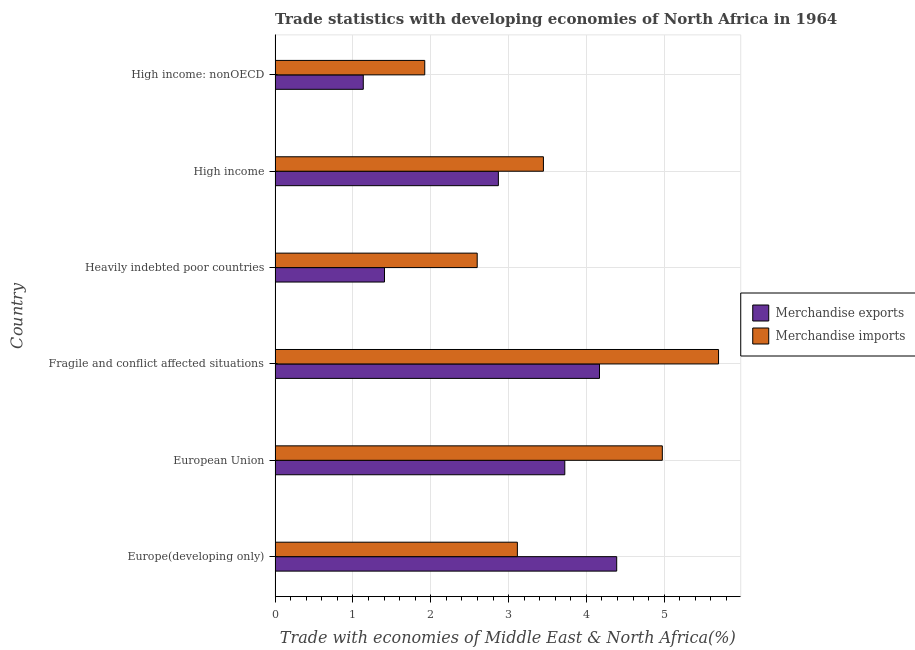How many different coloured bars are there?
Keep it short and to the point. 2. Are the number of bars on each tick of the Y-axis equal?
Provide a succinct answer. Yes. How many bars are there on the 1st tick from the bottom?
Ensure brevity in your answer.  2. What is the label of the 6th group of bars from the top?
Your response must be concise. Europe(developing only). What is the merchandise exports in Europe(developing only)?
Offer a very short reply. 4.39. Across all countries, what is the maximum merchandise exports?
Give a very brief answer. 4.39. Across all countries, what is the minimum merchandise exports?
Your answer should be very brief. 1.13. In which country was the merchandise exports maximum?
Give a very brief answer. Europe(developing only). In which country was the merchandise exports minimum?
Offer a terse response. High income: nonOECD. What is the total merchandise imports in the graph?
Your answer should be compact. 21.76. What is the difference between the merchandise imports in European Union and that in High income?
Provide a short and direct response. 1.53. What is the difference between the merchandise imports in High income and the merchandise exports in High income: nonOECD?
Offer a very short reply. 2.31. What is the average merchandise exports per country?
Ensure brevity in your answer.  2.95. What is the difference between the merchandise imports and merchandise exports in Fragile and conflict affected situations?
Offer a terse response. 1.53. In how many countries, is the merchandise imports greater than 0.2 %?
Ensure brevity in your answer.  6. What is the ratio of the merchandise imports in Fragile and conflict affected situations to that in High income?
Ensure brevity in your answer.  1.65. Is the merchandise exports in Fragile and conflict affected situations less than that in High income: nonOECD?
Offer a very short reply. No. What is the difference between the highest and the second highest merchandise imports?
Make the answer very short. 0.72. What is the difference between the highest and the lowest merchandise exports?
Your answer should be very brief. 3.26. What does the 2nd bar from the top in High income represents?
Offer a very short reply. Merchandise exports. What does the 1st bar from the bottom in Fragile and conflict affected situations represents?
Your answer should be compact. Merchandise exports. Are all the bars in the graph horizontal?
Provide a succinct answer. Yes. Are the values on the major ticks of X-axis written in scientific E-notation?
Give a very brief answer. No. Where does the legend appear in the graph?
Make the answer very short. Center right. How are the legend labels stacked?
Keep it short and to the point. Vertical. What is the title of the graph?
Keep it short and to the point. Trade statistics with developing economies of North Africa in 1964. What is the label or title of the X-axis?
Offer a very short reply. Trade with economies of Middle East & North Africa(%). What is the label or title of the Y-axis?
Your response must be concise. Country. What is the Trade with economies of Middle East & North Africa(%) of Merchandise exports in Europe(developing only)?
Provide a succinct answer. 4.39. What is the Trade with economies of Middle East & North Africa(%) in Merchandise imports in Europe(developing only)?
Offer a very short reply. 3.11. What is the Trade with economies of Middle East & North Africa(%) of Merchandise exports in European Union?
Offer a terse response. 3.72. What is the Trade with economies of Middle East & North Africa(%) in Merchandise imports in European Union?
Offer a terse response. 4.98. What is the Trade with economies of Middle East & North Africa(%) of Merchandise exports in Fragile and conflict affected situations?
Keep it short and to the point. 4.17. What is the Trade with economies of Middle East & North Africa(%) of Merchandise imports in Fragile and conflict affected situations?
Offer a terse response. 5.7. What is the Trade with economies of Middle East & North Africa(%) in Merchandise exports in Heavily indebted poor countries?
Offer a terse response. 1.41. What is the Trade with economies of Middle East & North Africa(%) in Merchandise imports in Heavily indebted poor countries?
Provide a short and direct response. 2.6. What is the Trade with economies of Middle East & North Africa(%) of Merchandise exports in High income?
Offer a terse response. 2.87. What is the Trade with economies of Middle East & North Africa(%) of Merchandise imports in High income?
Provide a succinct answer. 3.45. What is the Trade with economies of Middle East & North Africa(%) in Merchandise exports in High income: nonOECD?
Offer a terse response. 1.13. What is the Trade with economies of Middle East & North Africa(%) in Merchandise imports in High income: nonOECD?
Offer a terse response. 1.92. Across all countries, what is the maximum Trade with economies of Middle East & North Africa(%) in Merchandise exports?
Provide a succinct answer. 4.39. Across all countries, what is the maximum Trade with economies of Middle East & North Africa(%) in Merchandise imports?
Offer a terse response. 5.7. Across all countries, what is the minimum Trade with economies of Middle East & North Africa(%) in Merchandise exports?
Your response must be concise. 1.13. Across all countries, what is the minimum Trade with economies of Middle East & North Africa(%) of Merchandise imports?
Offer a terse response. 1.92. What is the total Trade with economies of Middle East & North Africa(%) of Merchandise exports in the graph?
Provide a short and direct response. 17.69. What is the total Trade with economies of Middle East & North Africa(%) in Merchandise imports in the graph?
Make the answer very short. 21.75. What is the difference between the Trade with economies of Middle East & North Africa(%) of Merchandise exports in Europe(developing only) and that in European Union?
Make the answer very short. 0.67. What is the difference between the Trade with economies of Middle East & North Africa(%) of Merchandise imports in Europe(developing only) and that in European Union?
Your answer should be very brief. -1.86. What is the difference between the Trade with economies of Middle East & North Africa(%) of Merchandise exports in Europe(developing only) and that in Fragile and conflict affected situations?
Provide a succinct answer. 0.22. What is the difference between the Trade with economies of Middle East & North Africa(%) of Merchandise imports in Europe(developing only) and that in Fragile and conflict affected situations?
Your answer should be compact. -2.58. What is the difference between the Trade with economies of Middle East & North Africa(%) of Merchandise exports in Europe(developing only) and that in Heavily indebted poor countries?
Your answer should be compact. 2.98. What is the difference between the Trade with economies of Middle East & North Africa(%) in Merchandise imports in Europe(developing only) and that in Heavily indebted poor countries?
Provide a succinct answer. 0.52. What is the difference between the Trade with economies of Middle East & North Africa(%) in Merchandise exports in Europe(developing only) and that in High income?
Provide a succinct answer. 1.52. What is the difference between the Trade with economies of Middle East & North Africa(%) of Merchandise imports in Europe(developing only) and that in High income?
Offer a very short reply. -0.33. What is the difference between the Trade with economies of Middle East & North Africa(%) of Merchandise exports in Europe(developing only) and that in High income: nonOECD?
Your answer should be compact. 3.26. What is the difference between the Trade with economies of Middle East & North Africa(%) in Merchandise imports in Europe(developing only) and that in High income: nonOECD?
Give a very brief answer. 1.19. What is the difference between the Trade with economies of Middle East & North Africa(%) in Merchandise exports in European Union and that in Fragile and conflict affected situations?
Your response must be concise. -0.45. What is the difference between the Trade with economies of Middle East & North Africa(%) in Merchandise imports in European Union and that in Fragile and conflict affected situations?
Provide a short and direct response. -0.72. What is the difference between the Trade with economies of Middle East & North Africa(%) in Merchandise exports in European Union and that in Heavily indebted poor countries?
Keep it short and to the point. 2.32. What is the difference between the Trade with economies of Middle East & North Africa(%) in Merchandise imports in European Union and that in Heavily indebted poor countries?
Provide a short and direct response. 2.38. What is the difference between the Trade with economies of Middle East & North Africa(%) in Merchandise exports in European Union and that in High income?
Provide a succinct answer. 0.85. What is the difference between the Trade with economies of Middle East & North Africa(%) in Merchandise imports in European Union and that in High income?
Offer a very short reply. 1.53. What is the difference between the Trade with economies of Middle East & North Africa(%) of Merchandise exports in European Union and that in High income: nonOECD?
Ensure brevity in your answer.  2.59. What is the difference between the Trade with economies of Middle East & North Africa(%) of Merchandise imports in European Union and that in High income: nonOECD?
Give a very brief answer. 3.05. What is the difference between the Trade with economies of Middle East & North Africa(%) in Merchandise exports in Fragile and conflict affected situations and that in Heavily indebted poor countries?
Make the answer very short. 2.76. What is the difference between the Trade with economies of Middle East & North Africa(%) in Merchandise imports in Fragile and conflict affected situations and that in Heavily indebted poor countries?
Offer a very short reply. 3.1. What is the difference between the Trade with economies of Middle East & North Africa(%) of Merchandise exports in Fragile and conflict affected situations and that in High income?
Keep it short and to the point. 1.3. What is the difference between the Trade with economies of Middle East & North Africa(%) of Merchandise imports in Fragile and conflict affected situations and that in High income?
Your answer should be very brief. 2.25. What is the difference between the Trade with economies of Middle East & North Africa(%) of Merchandise exports in Fragile and conflict affected situations and that in High income: nonOECD?
Your answer should be very brief. 3.04. What is the difference between the Trade with economies of Middle East & North Africa(%) in Merchandise imports in Fragile and conflict affected situations and that in High income: nonOECD?
Offer a terse response. 3.77. What is the difference between the Trade with economies of Middle East & North Africa(%) in Merchandise exports in Heavily indebted poor countries and that in High income?
Your answer should be very brief. -1.46. What is the difference between the Trade with economies of Middle East & North Africa(%) of Merchandise imports in Heavily indebted poor countries and that in High income?
Make the answer very short. -0.85. What is the difference between the Trade with economies of Middle East & North Africa(%) of Merchandise exports in Heavily indebted poor countries and that in High income: nonOECD?
Keep it short and to the point. 0.27. What is the difference between the Trade with economies of Middle East & North Africa(%) in Merchandise imports in Heavily indebted poor countries and that in High income: nonOECD?
Your answer should be compact. 0.67. What is the difference between the Trade with economies of Middle East & North Africa(%) in Merchandise exports in High income and that in High income: nonOECD?
Keep it short and to the point. 1.74. What is the difference between the Trade with economies of Middle East & North Africa(%) in Merchandise imports in High income and that in High income: nonOECD?
Your answer should be very brief. 1.52. What is the difference between the Trade with economies of Middle East & North Africa(%) of Merchandise exports in Europe(developing only) and the Trade with economies of Middle East & North Africa(%) of Merchandise imports in European Union?
Offer a very short reply. -0.59. What is the difference between the Trade with economies of Middle East & North Africa(%) of Merchandise exports in Europe(developing only) and the Trade with economies of Middle East & North Africa(%) of Merchandise imports in Fragile and conflict affected situations?
Ensure brevity in your answer.  -1.31. What is the difference between the Trade with economies of Middle East & North Africa(%) of Merchandise exports in Europe(developing only) and the Trade with economies of Middle East & North Africa(%) of Merchandise imports in Heavily indebted poor countries?
Ensure brevity in your answer.  1.79. What is the difference between the Trade with economies of Middle East & North Africa(%) in Merchandise exports in Europe(developing only) and the Trade with economies of Middle East & North Africa(%) in Merchandise imports in High income?
Offer a terse response. 0.94. What is the difference between the Trade with economies of Middle East & North Africa(%) of Merchandise exports in Europe(developing only) and the Trade with economies of Middle East & North Africa(%) of Merchandise imports in High income: nonOECD?
Offer a terse response. 2.47. What is the difference between the Trade with economies of Middle East & North Africa(%) of Merchandise exports in European Union and the Trade with economies of Middle East & North Africa(%) of Merchandise imports in Fragile and conflict affected situations?
Your answer should be very brief. -1.98. What is the difference between the Trade with economies of Middle East & North Africa(%) in Merchandise exports in European Union and the Trade with economies of Middle East & North Africa(%) in Merchandise imports in Heavily indebted poor countries?
Keep it short and to the point. 1.13. What is the difference between the Trade with economies of Middle East & North Africa(%) of Merchandise exports in European Union and the Trade with economies of Middle East & North Africa(%) of Merchandise imports in High income?
Provide a succinct answer. 0.27. What is the difference between the Trade with economies of Middle East & North Africa(%) in Merchandise exports in European Union and the Trade with economies of Middle East & North Africa(%) in Merchandise imports in High income: nonOECD?
Keep it short and to the point. 1.8. What is the difference between the Trade with economies of Middle East & North Africa(%) in Merchandise exports in Fragile and conflict affected situations and the Trade with economies of Middle East & North Africa(%) in Merchandise imports in Heavily indebted poor countries?
Your answer should be very brief. 1.57. What is the difference between the Trade with economies of Middle East & North Africa(%) in Merchandise exports in Fragile and conflict affected situations and the Trade with economies of Middle East & North Africa(%) in Merchandise imports in High income?
Ensure brevity in your answer.  0.72. What is the difference between the Trade with economies of Middle East & North Africa(%) of Merchandise exports in Fragile and conflict affected situations and the Trade with economies of Middle East & North Africa(%) of Merchandise imports in High income: nonOECD?
Provide a succinct answer. 2.25. What is the difference between the Trade with economies of Middle East & North Africa(%) in Merchandise exports in Heavily indebted poor countries and the Trade with economies of Middle East & North Africa(%) in Merchandise imports in High income?
Offer a very short reply. -2.04. What is the difference between the Trade with economies of Middle East & North Africa(%) in Merchandise exports in Heavily indebted poor countries and the Trade with economies of Middle East & North Africa(%) in Merchandise imports in High income: nonOECD?
Provide a succinct answer. -0.52. What is the difference between the Trade with economies of Middle East & North Africa(%) of Merchandise exports in High income and the Trade with economies of Middle East & North Africa(%) of Merchandise imports in High income: nonOECD?
Offer a terse response. 0.95. What is the average Trade with economies of Middle East & North Africa(%) in Merchandise exports per country?
Your response must be concise. 2.95. What is the average Trade with economies of Middle East & North Africa(%) of Merchandise imports per country?
Make the answer very short. 3.63. What is the difference between the Trade with economies of Middle East & North Africa(%) of Merchandise exports and Trade with economies of Middle East & North Africa(%) of Merchandise imports in Europe(developing only)?
Ensure brevity in your answer.  1.28. What is the difference between the Trade with economies of Middle East & North Africa(%) of Merchandise exports and Trade with economies of Middle East & North Africa(%) of Merchandise imports in European Union?
Provide a short and direct response. -1.25. What is the difference between the Trade with economies of Middle East & North Africa(%) of Merchandise exports and Trade with economies of Middle East & North Africa(%) of Merchandise imports in Fragile and conflict affected situations?
Provide a succinct answer. -1.53. What is the difference between the Trade with economies of Middle East & North Africa(%) in Merchandise exports and Trade with economies of Middle East & North Africa(%) in Merchandise imports in Heavily indebted poor countries?
Ensure brevity in your answer.  -1.19. What is the difference between the Trade with economies of Middle East & North Africa(%) of Merchandise exports and Trade with economies of Middle East & North Africa(%) of Merchandise imports in High income?
Give a very brief answer. -0.58. What is the difference between the Trade with economies of Middle East & North Africa(%) in Merchandise exports and Trade with economies of Middle East & North Africa(%) in Merchandise imports in High income: nonOECD?
Provide a short and direct response. -0.79. What is the ratio of the Trade with economies of Middle East & North Africa(%) in Merchandise exports in Europe(developing only) to that in European Union?
Your answer should be compact. 1.18. What is the ratio of the Trade with economies of Middle East & North Africa(%) in Merchandise imports in Europe(developing only) to that in European Union?
Ensure brevity in your answer.  0.63. What is the ratio of the Trade with economies of Middle East & North Africa(%) of Merchandise exports in Europe(developing only) to that in Fragile and conflict affected situations?
Your answer should be compact. 1.05. What is the ratio of the Trade with economies of Middle East & North Africa(%) in Merchandise imports in Europe(developing only) to that in Fragile and conflict affected situations?
Your answer should be compact. 0.55. What is the ratio of the Trade with economies of Middle East & North Africa(%) in Merchandise exports in Europe(developing only) to that in Heavily indebted poor countries?
Provide a succinct answer. 3.12. What is the ratio of the Trade with economies of Middle East & North Africa(%) of Merchandise imports in Europe(developing only) to that in Heavily indebted poor countries?
Your response must be concise. 1.2. What is the ratio of the Trade with economies of Middle East & North Africa(%) of Merchandise exports in Europe(developing only) to that in High income?
Keep it short and to the point. 1.53. What is the ratio of the Trade with economies of Middle East & North Africa(%) of Merchandise imports in Europe(developing only) to that in High income?
Your response must be concise. 0.9. What is the ratio of the Trade with economies of Middle East & North Africa(%) of Merchandise exports in Europe(developing only) to that in High income: nonOECD?
Offer a very short reply. 3.87. What is the ratio of the Trade with economies of Middle East & North Africa(%) in Merchandise imports in Europe(developing only) to that in High income: nonOECD?
Your answer should be very brief. 1.62. What is the ratio of the Trade with economies of Middle East & North Africa(%) of Merchandise exports in European Union to that in Fragile and conflict affected situations?
Your answer should be compact. 0.89. What is the ratio of the Trade with economies of Middle East & North Africa(%) of Merchandise imports in European Union to that in Fragile and conflict affected situations?
Provide a short and direct response. 0.87. What is the ratio of the Trade with economies of Middle East & North Africa(%) of Merchandise exports in European Union to that in Heavily indebted poor countries?
Provide a succinct answer. 2.65. What is the ratio of the Trade with economies of Middle East & North Africa(%) of Merchandise imports in European Union to that in Heavily indebted poor countries?
Offer a terse response. 1.92. What is the ratio of the Trade with economies of Middle East & North Africa(%) of Merchandise exports in European Union to that in High income?
Provide a short and direct response. 1.3. What is the ratio of the Trade with economies of Middle East & North Africa(%) of Merchandise imports in European Union to that in High income?
Provide a succinct answer. 1.44. What is the ratio of the Trade with economies of Middle East & North Africa(%) in Merchandise exports in European Union to that in High income: nonOECD?
Provide a short and direct response. 3.28. What is the ratio of the Trade with economies of Middle East & North Africa(%) of Merchandise imports in European Union to that in High income: nonOECD?
Keep it short and to the point. 2.59. What is the ratio of the Trade with economies of Middle East & North Africa(%) of Merchandise exports in Fragile and conflict affected situations to that in Heavily indebted poor countries?
Keep it short and to the point. 2.96. What is the ratio of the Trade with economies of Middle East & North Africa(%) of Merchandise imports in Fragile and conflict affected situations to that in Heavily indebted poor countries?
Offer a terse response. 2.19. What is the ratio of the Trade with economies of Middle East & North Africa(%) in Merchandise exports in Fragile and conflict affected situations to that in High income?
Provide a succinct answer. 1.45. What is the ratio of the Trade with economies of Middle East & North Africa(%) of Merchandise imports in Fragile and conflict affected situations to that in High income?
Offer a terse response. 1.65. What is the ratio of the Trade with economies of Middle East & North Africa(%) of Merchandise exports in Fragile and conflict affected situations to that in High income: nonOECD?
Offer a very short reply. 3.68. What is the ratio of the Trade with economies of Middle East & North Africa(%) in Merchandise imports in Fragile and conflict affected situations to that in High income: nonOECD?
Make the answer very short. 2.96. What is the ratio of the Trade with economies of Middle East & North Africa(%) of Merchandise exports in Heavily indebted poor countries to that in High income?
Make the answer very short. 0.49. What is the ratio of the Trade with economies of Middle East & North Africa(%) of Merchandise imports in Heavily indebted poor countries to that in High income?
Your answer should be compact. 0.75. What is the ratio of the Trade with economies of Middle East & North Africa(%) of Merchandise exports in Heavily indebted poor countries to that in High income: nonOECD?
Keep it short and to the point. 1.24. What is the ratio of the Trade with economies of Middle East & North Africa(%) in Merchandise imports in Heavily indebted poor countries to that in High income: nonOECD?
Your answer should be compact. 1.35. What is the ratio of the Trade with economies of Middle East & North Africa(%) of Merchandise exports in High income to that in High income: nonOECD?
Keep it short and to the point. 2.53. What is the ratio of the Trade with economies of Middle East & North Africa(%) of Merchandise imports in High income to that in High income: nonOECD?
Make the answer very short. 1.79. What is the difference between the highest and the second highest Trade with economies of Middle East & North Africa(%) of Merchandise exports?
Your answer should be compact. 0.22. What is the difference between the highest and the second highest Trade with economies of Middle East & North Africa(%) of Merchandise imports?
Provide a succinct answer. 0.72. What is the difference between the highest and the lowest Trade with economies of Middle East & North Africa(%) in Merchandise exports?
Your answer should be compact. 3.26. What is the difference between the highest and the lowest Trade with economies of Middle East & North Africa(%) of Merchandise imports?
Your answer should be compact. 3.77. 